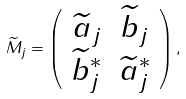Convert formula to latex. <formula><loc_0><loc_0><loc_500><loc_500>\widetilde { M } _ { j } = \left ( \begin{array} { c c } \widetilde { a } _ { j } & \widetilde { b } _ { j } \\ \widetilde { b } ^ { \ast } _ { j } & \widetilde { a } ^ { \ast } _ { j } \end{array} \right ) ,</formula> 